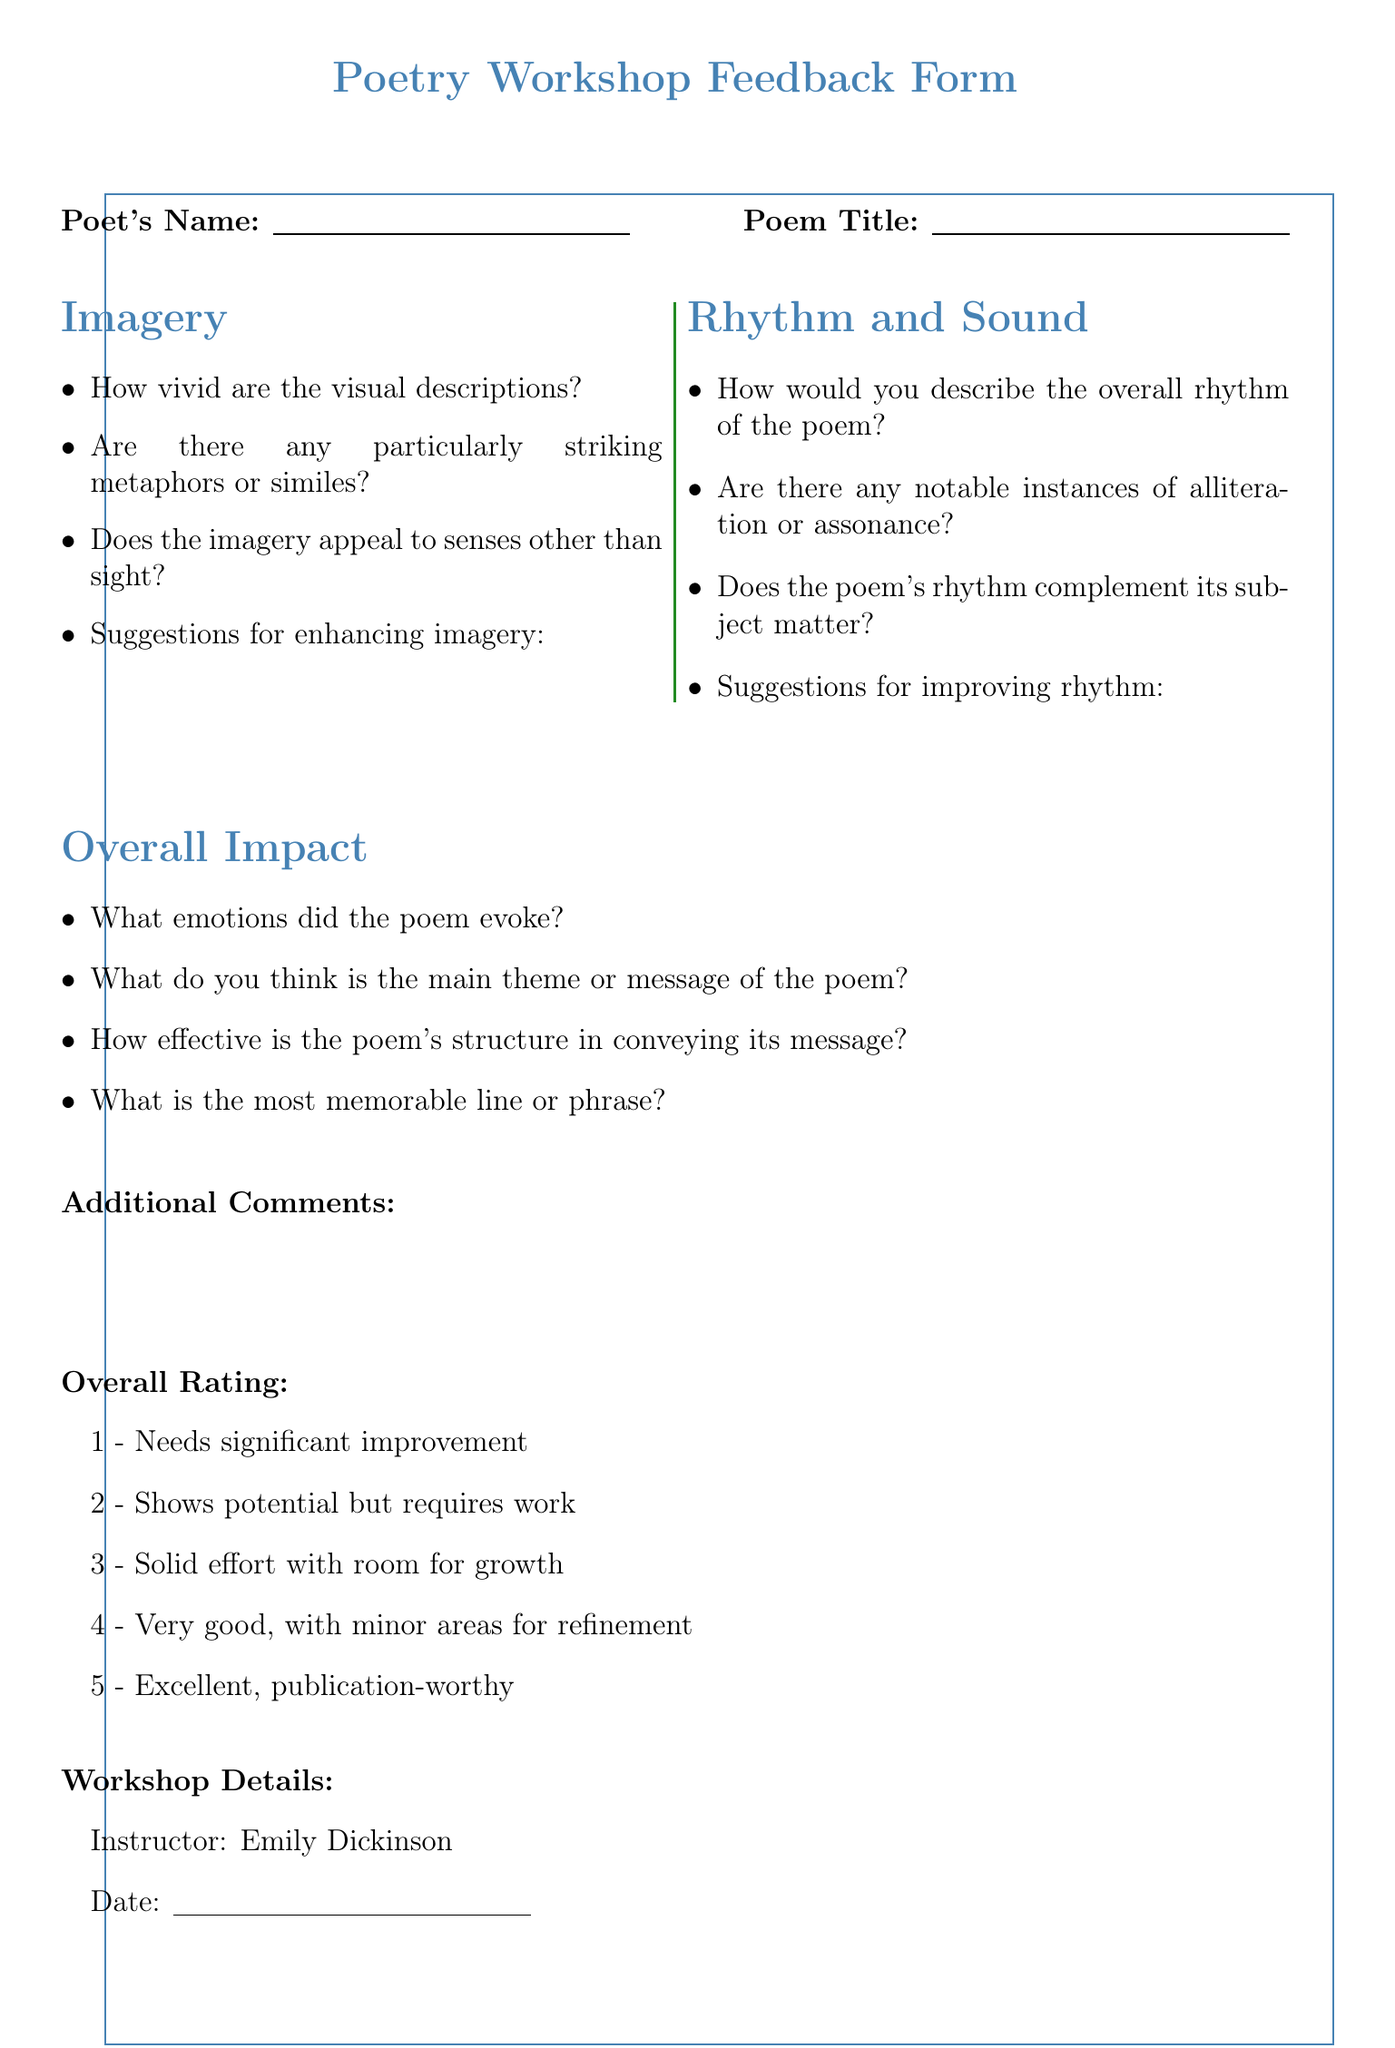What is the title of the feedback form? The title of the feedback form is stated at the beginning of the document as "Poetry Workshop Feedback Form."
Answer: Poetry Workshop Feedback Form Who is the instructor of the workshop? The instructor's name is listed under the workshop details section.
Answer: Emily Dickinson What is the location of the workshop? The workshop's location is specified in the details provided in the document.
Answer: Amherst College Creative Writing Center How many questions are there in the Imagery section? The number of questions in the Imagery section can be counted directly from the list in that section.
Answer: 4 What is the first suggested resource for further study? The first recommended resource is the title listed in the recommended resources section.
Answer: The Poet's Companion by Kim Addonizio and Dorianne Laux What is the overall rating option for "Needs significant improvement"? The rating options are explicitly listed, with the first option for the lowest rating.
Answer: 1 - Needs significant improvement What is the theme of the poetry workshop as implied by the document? The overall focus of the workshop is implied in the document's content related to poetic techniques such as imagery and rhythm.
Answer: Poetry What is the main emotion to evoke from participants in the Overall Impact section? The Overall Impact section includes a question about which emotions the poem evokes.
Answer: Emotions What is the overall structure of the document? The structure can be inferred from the organization of the sections in the feedback form.
Answer: Feedback form with sections on imagery, rhythm, overall impact, and resources 